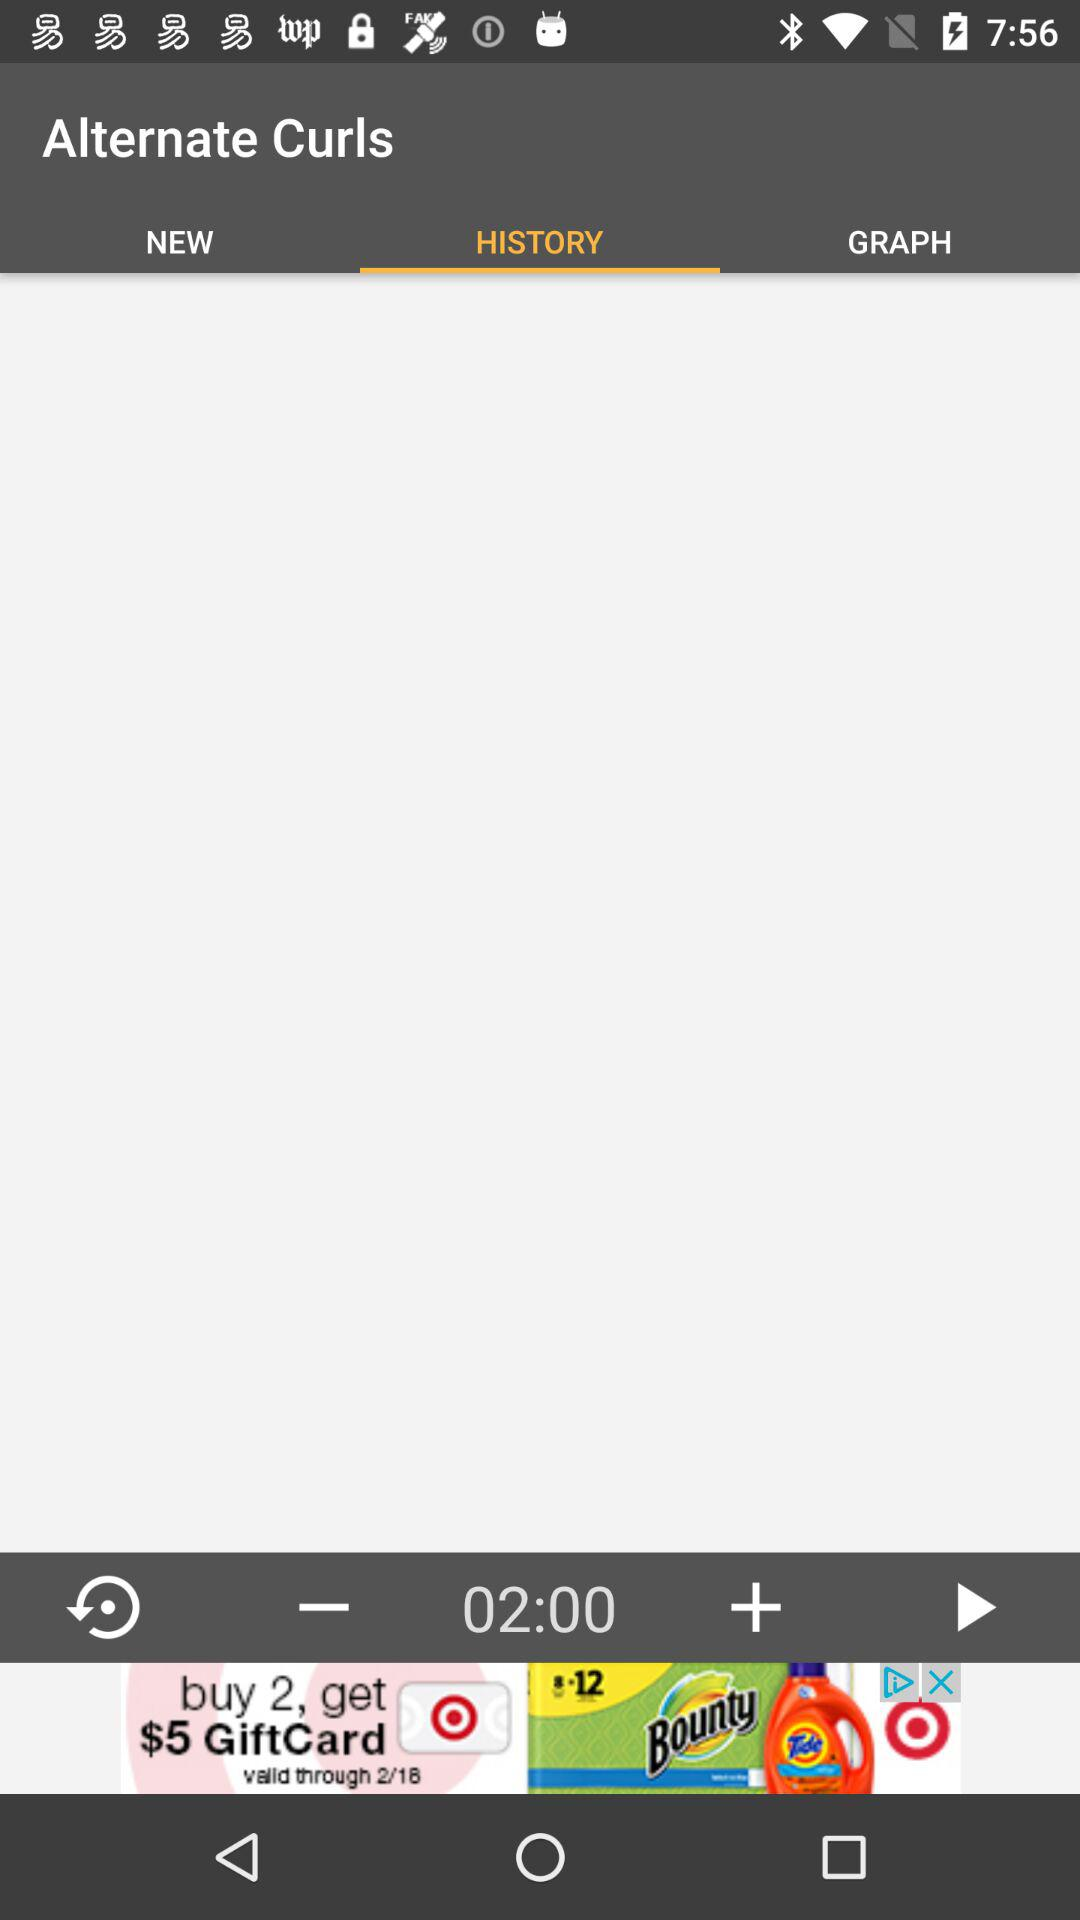How many minutes are selected? There are 2 selected minutes. 